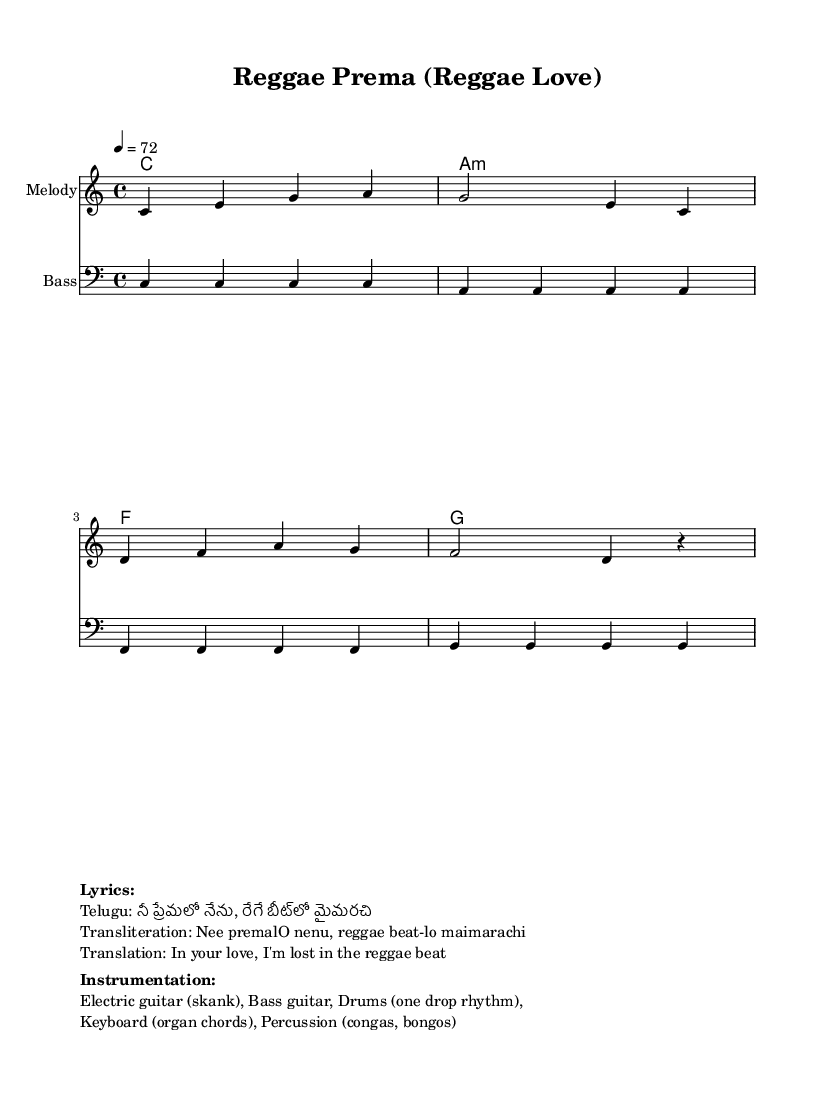What is the key signature of this music? The key signature is C major, which has no sharps or flats indicated in the score.
Answer: C major What is the time signature of the piece? The time signature shown in the score is 4/4, meaning there are four beats in each measure.
Answer: 4/4 What is the tempo of the music? The tempo marking is indicated as 4 = 72, meaning that there are 72 quarter note beats per minute.
Answer: 72 How many measures does the melody consist of? The melody part has a total of four measures represented in the score.
Answer: Four measures What instruments are mentioned for the reggae sound? The score includes electric guitar, bass guitar, drums, keyboard, and percussion.
Answer: Electric guitar, bass guitar, drums, keyboard, percussion What is the lyrical theme expressed in the song? The lyrics express being lost in love and music, particularly a reggae beat, which is typical of romantic reggae love songs.
Answer: Love and music How does the harmony progress in the score? The harmony moves through a sequence of C major, A minor, F major, and G major chords, indicating a common reggae progression.
Answer: C, A minor, F, G 